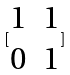<formula> <loc_0><loc_0><loc_500><loc_500>[ \begin{matrix} 1 & 1 \\ 0 & 1 \end{matrix} ]</formula> 